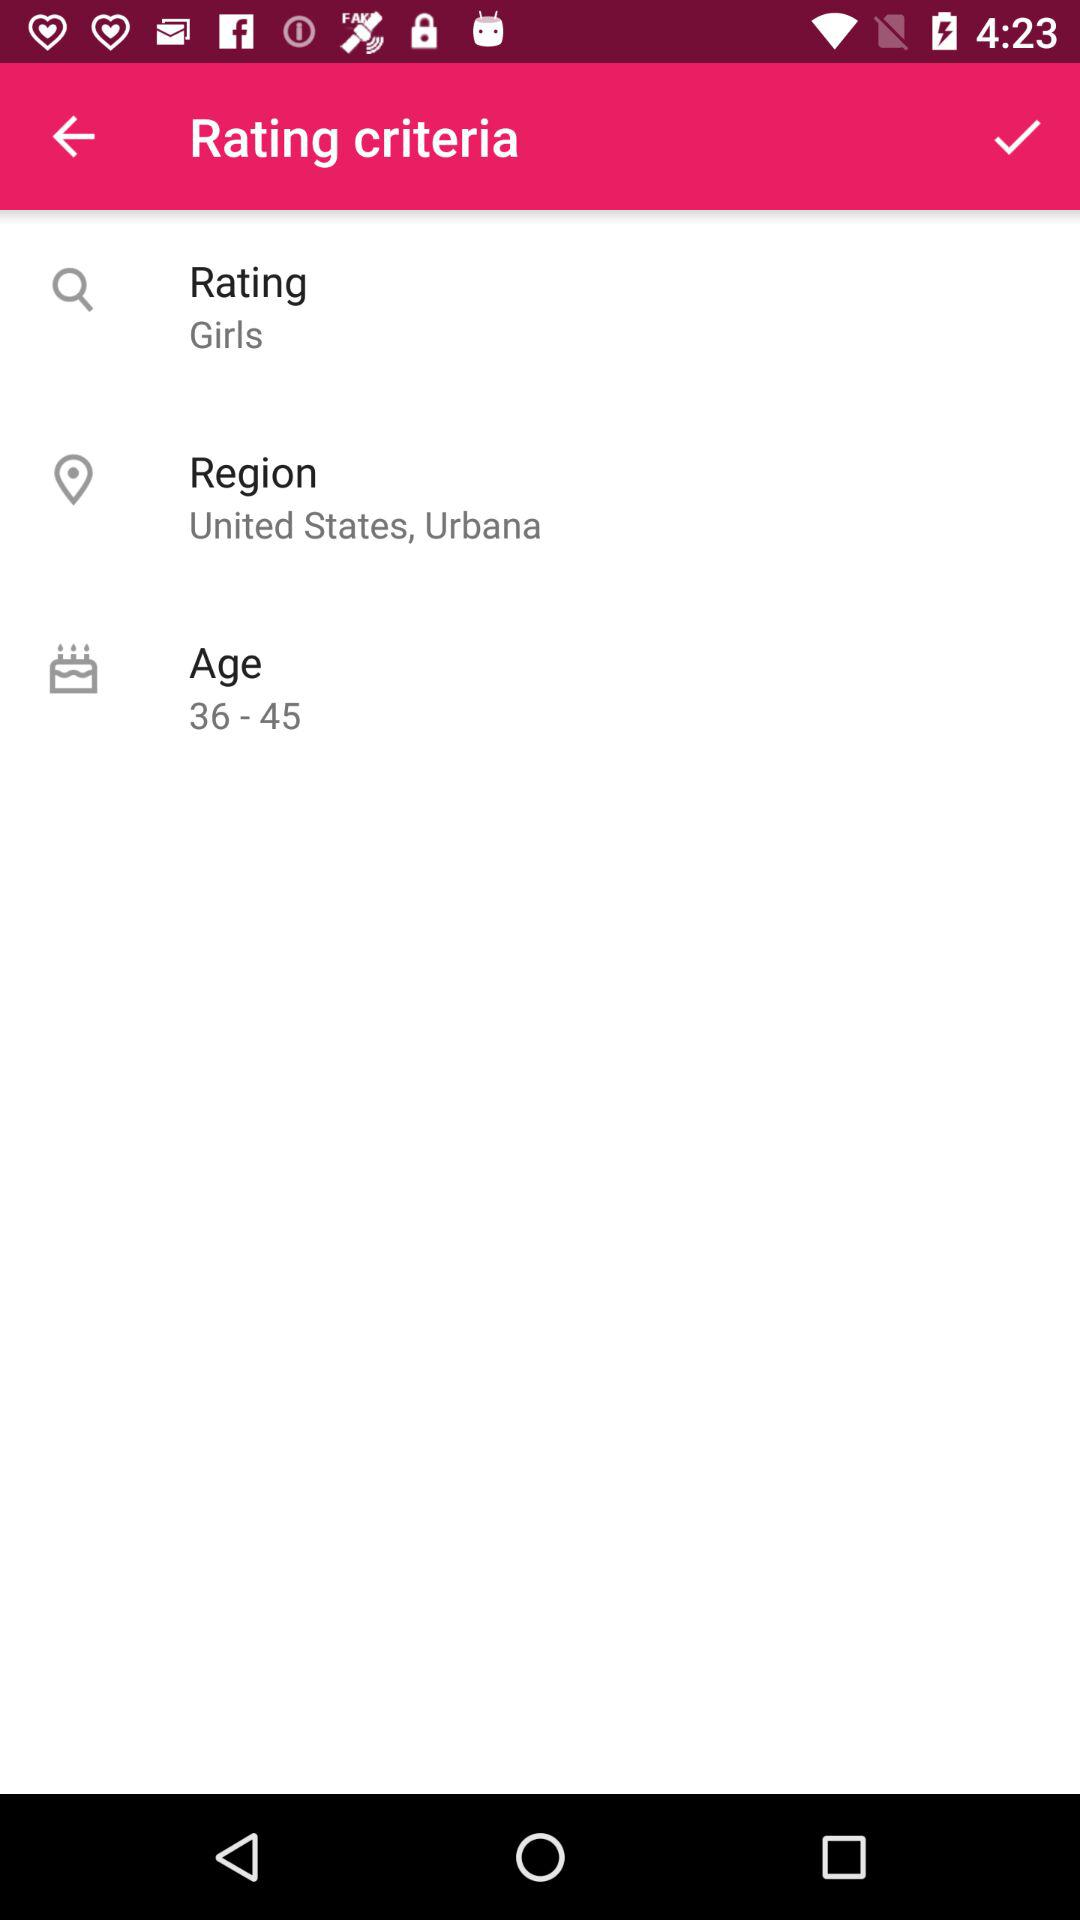Which region has been selected in "Rating criteria"? The region that has been selected in "Rating criteria" is Urbana, United States. 